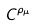<formula> <loc_0><loc_0><loc_500><loc_500>C ^ { \rho _ { \mu } }</formula> 